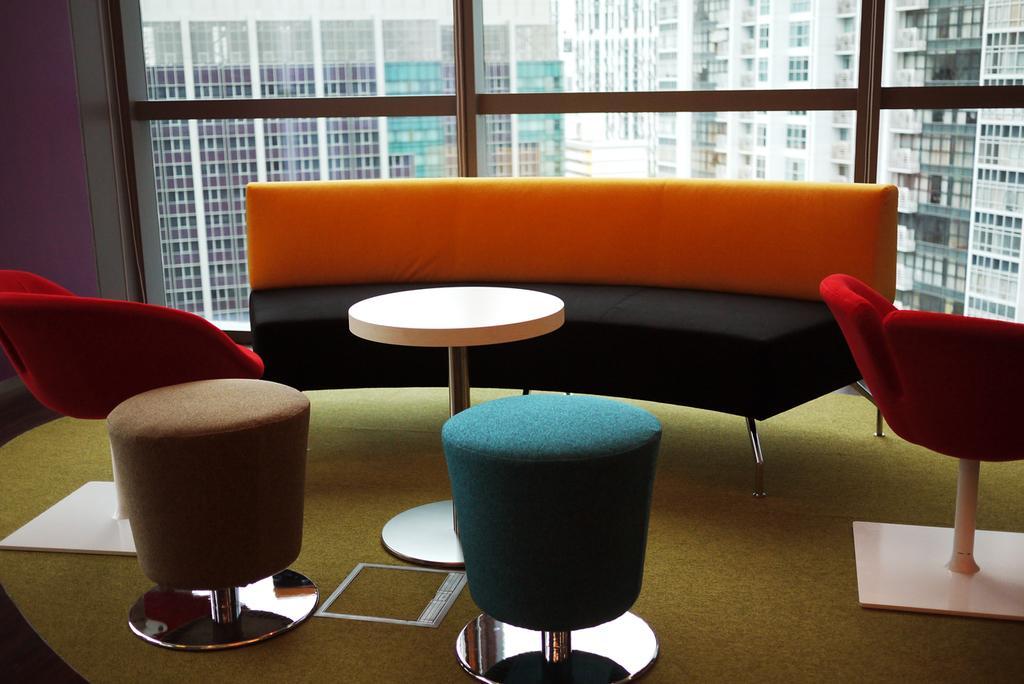Describe this image in one or two sentences. In this image I can see a sofa and few chairs. In the background I can see few buildings. 